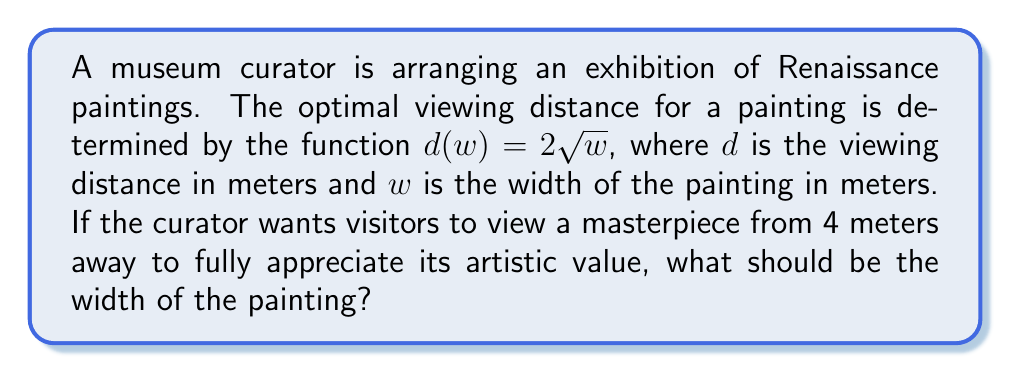Could you help me with this problem? To solve this problem, we need to use the given function and work backwards to find the width of the painting.

1. Given function: $d(w) = 2\sqrt{w}$
2. Desired viewing distance: $d = 4$ meters

Now, let's solve for $w$:

3. Substitute the known value: $4 = 2\sqrt{w}$
4. Divide both sides by 2: $2 = \sqrt{w}$
5. Square both sides to isolate $w$: $2^2 = (\sqrt{w})^2$
6. Simplify: $4 = w$

Therefore, the width of the painting should be 4 square meters to achieve the optimal viewing distance of 4 meters, allowing visitors to fully appreciate its artistic value.
Answer: $w = 4$ m² 